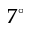<formula> <loc_0><loc_0><loc_500><loc_500>7 ^ { \circ }</formula> 